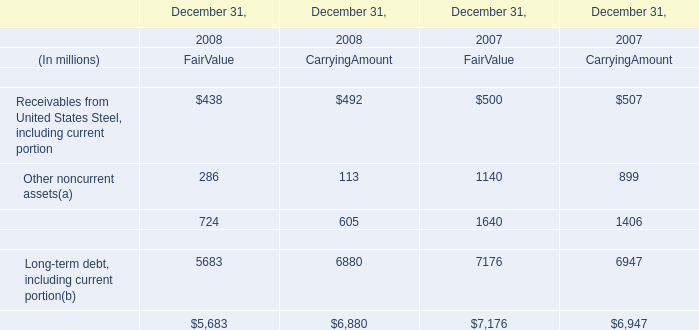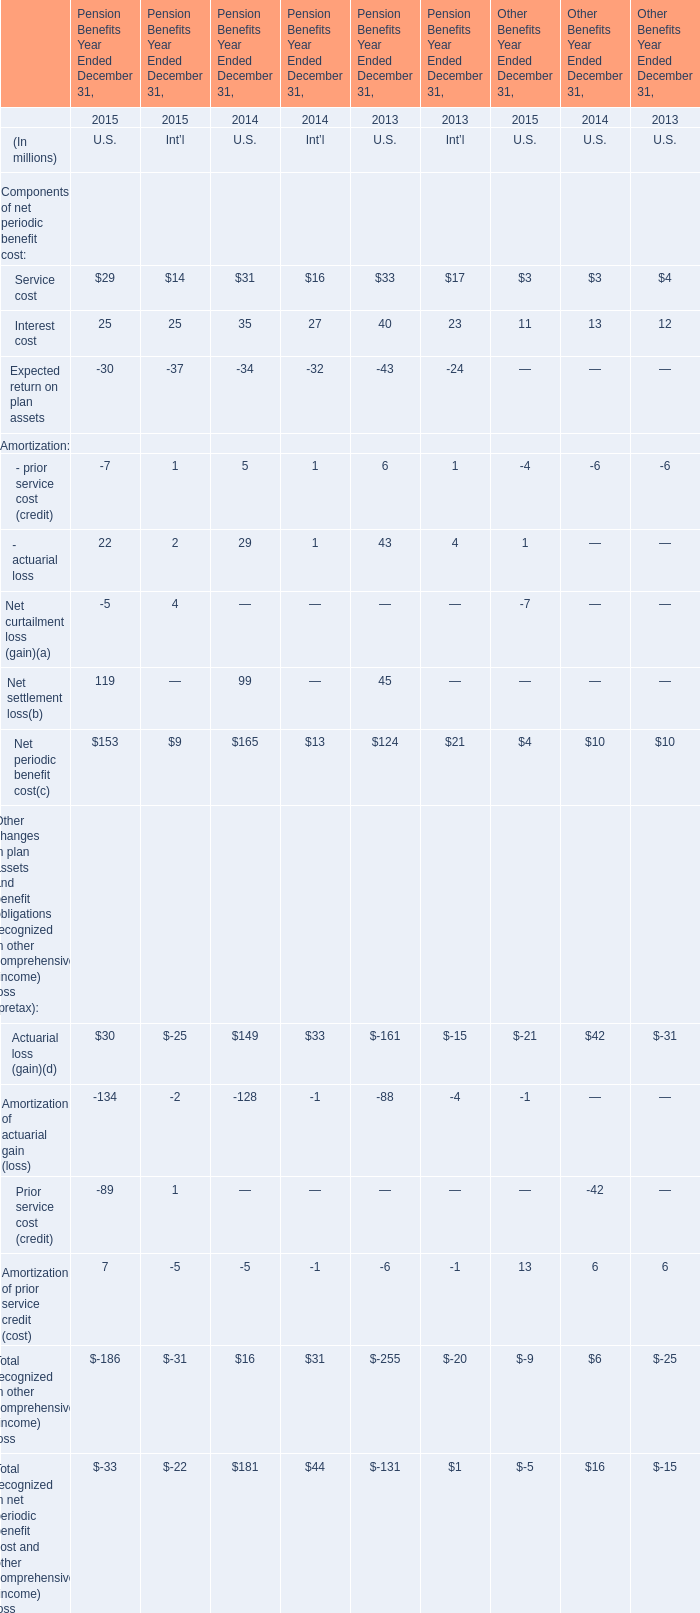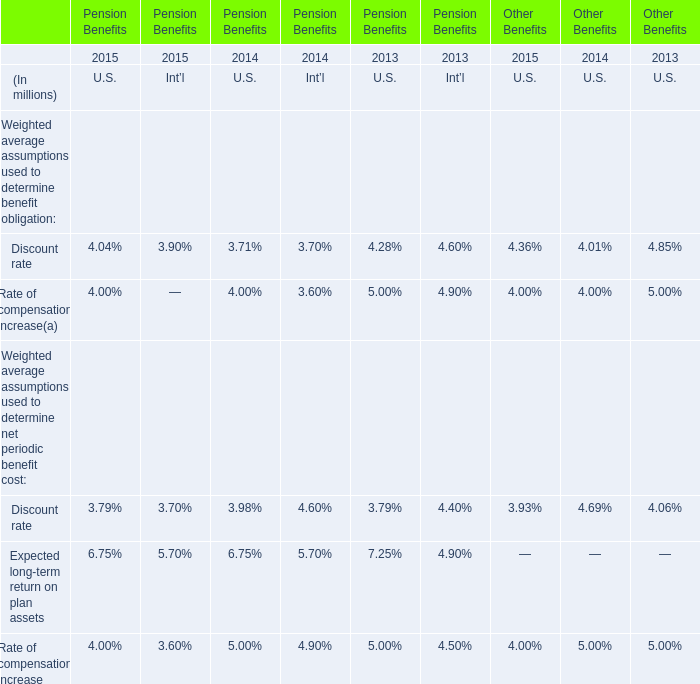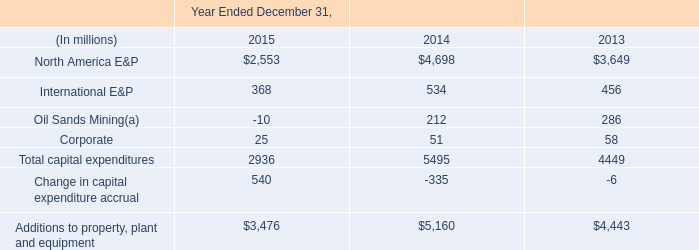during 2013 , what was the average cost per share acquired? 
Computations: (500 / 14)
Answer: 35.71429. 